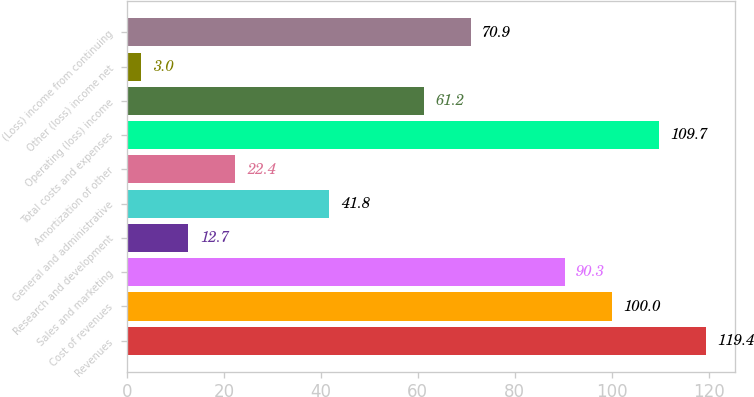<chart> <loc_0><loc_0><loc_500><loc_500><bar_chart><fcel>Revenues<fcel>Cost of revenues<fcel>Sales and marketing<fcel>Research and development<fcel>General and administrative<fcel>Amortization of other<fcel>Total costs and expenses<fcel>Operating (loss) income<fcel>Other (loss) income net<fcel>(Loss) income from continuing<nl><fcel>119.4<fcel>100<fcel>90.3<fcel>12.7<fcel>41.8<fcel>22.4<fcel>109.7<fcel>61.2<fcel>3<fcel>70.9<nl></chart> 